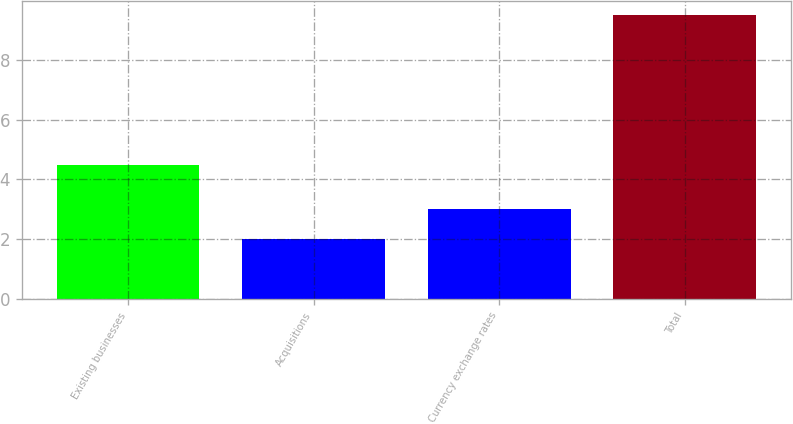Convert chart. <chart><loc_0><loc_0><loc_500><loc_500><bar_chart><fcel>Existing businesses<fcel>Acquisitions<fcel>Currency exchange rates<fcel>Total<nl><fcel>4.5<fcel>2<fcel>3<fcel>9.5<nl></chart> 